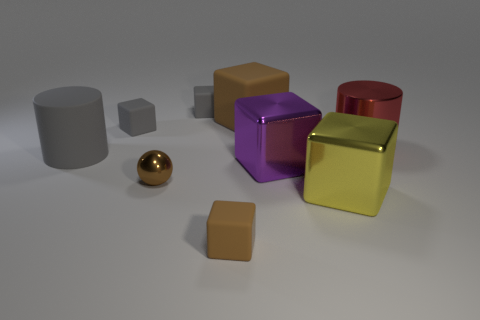Subtract all big rubber cubes. How many cubes are left? 5 Add 1 big matte cylinders. How many objects exist? 10 Subtract all yellow blocks. How many blocks are left? 5 Subtract all cubes. How many objects are left? 3 Subtract 2 cylinders. How many cylinders are left? 0 Add 9 tiny brown metal objects. How many tiny brown metal objects are left? 10 Add 1 big brown rubber cylinders. How many big brown rubber cylinders exist? 1 Subtract 0 green cylinders. How many objects are left? 9 Subtract all gray cylinders. Subtract all purple blocks. How many cylinders are left? 1 Subtract all red balls. How many green cubes are left? 0 